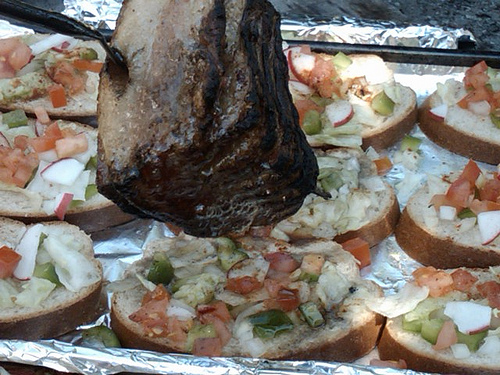<image>
Is there a meat above the bre? Yes. The meat is positioned above the bre in the vertical space, higher up in the scene. 